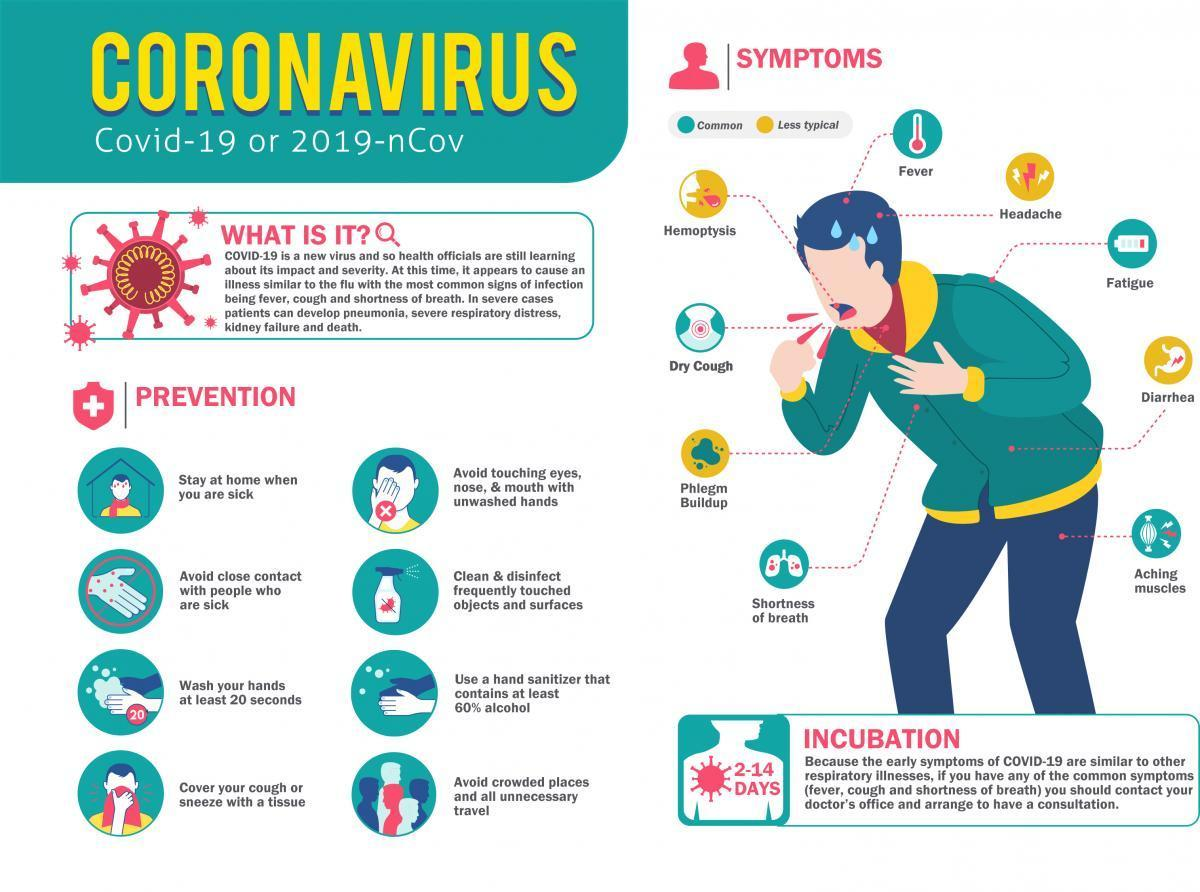What is the colour of the cloth used to cover the face, red or yellow
Answer the question with a short phrase. red What should you do when you are sick stay at home what are the less typical symptoms other than phlegm buildup Hemoptysis, Headache, Diarrhea What is the incubation period 2-14 days What is the number written in the hand washing image 20 What type of symptom is dry cough and fatigue common What does the spray bottle indicate clean & disinfect frequently touched objects and surfaces 